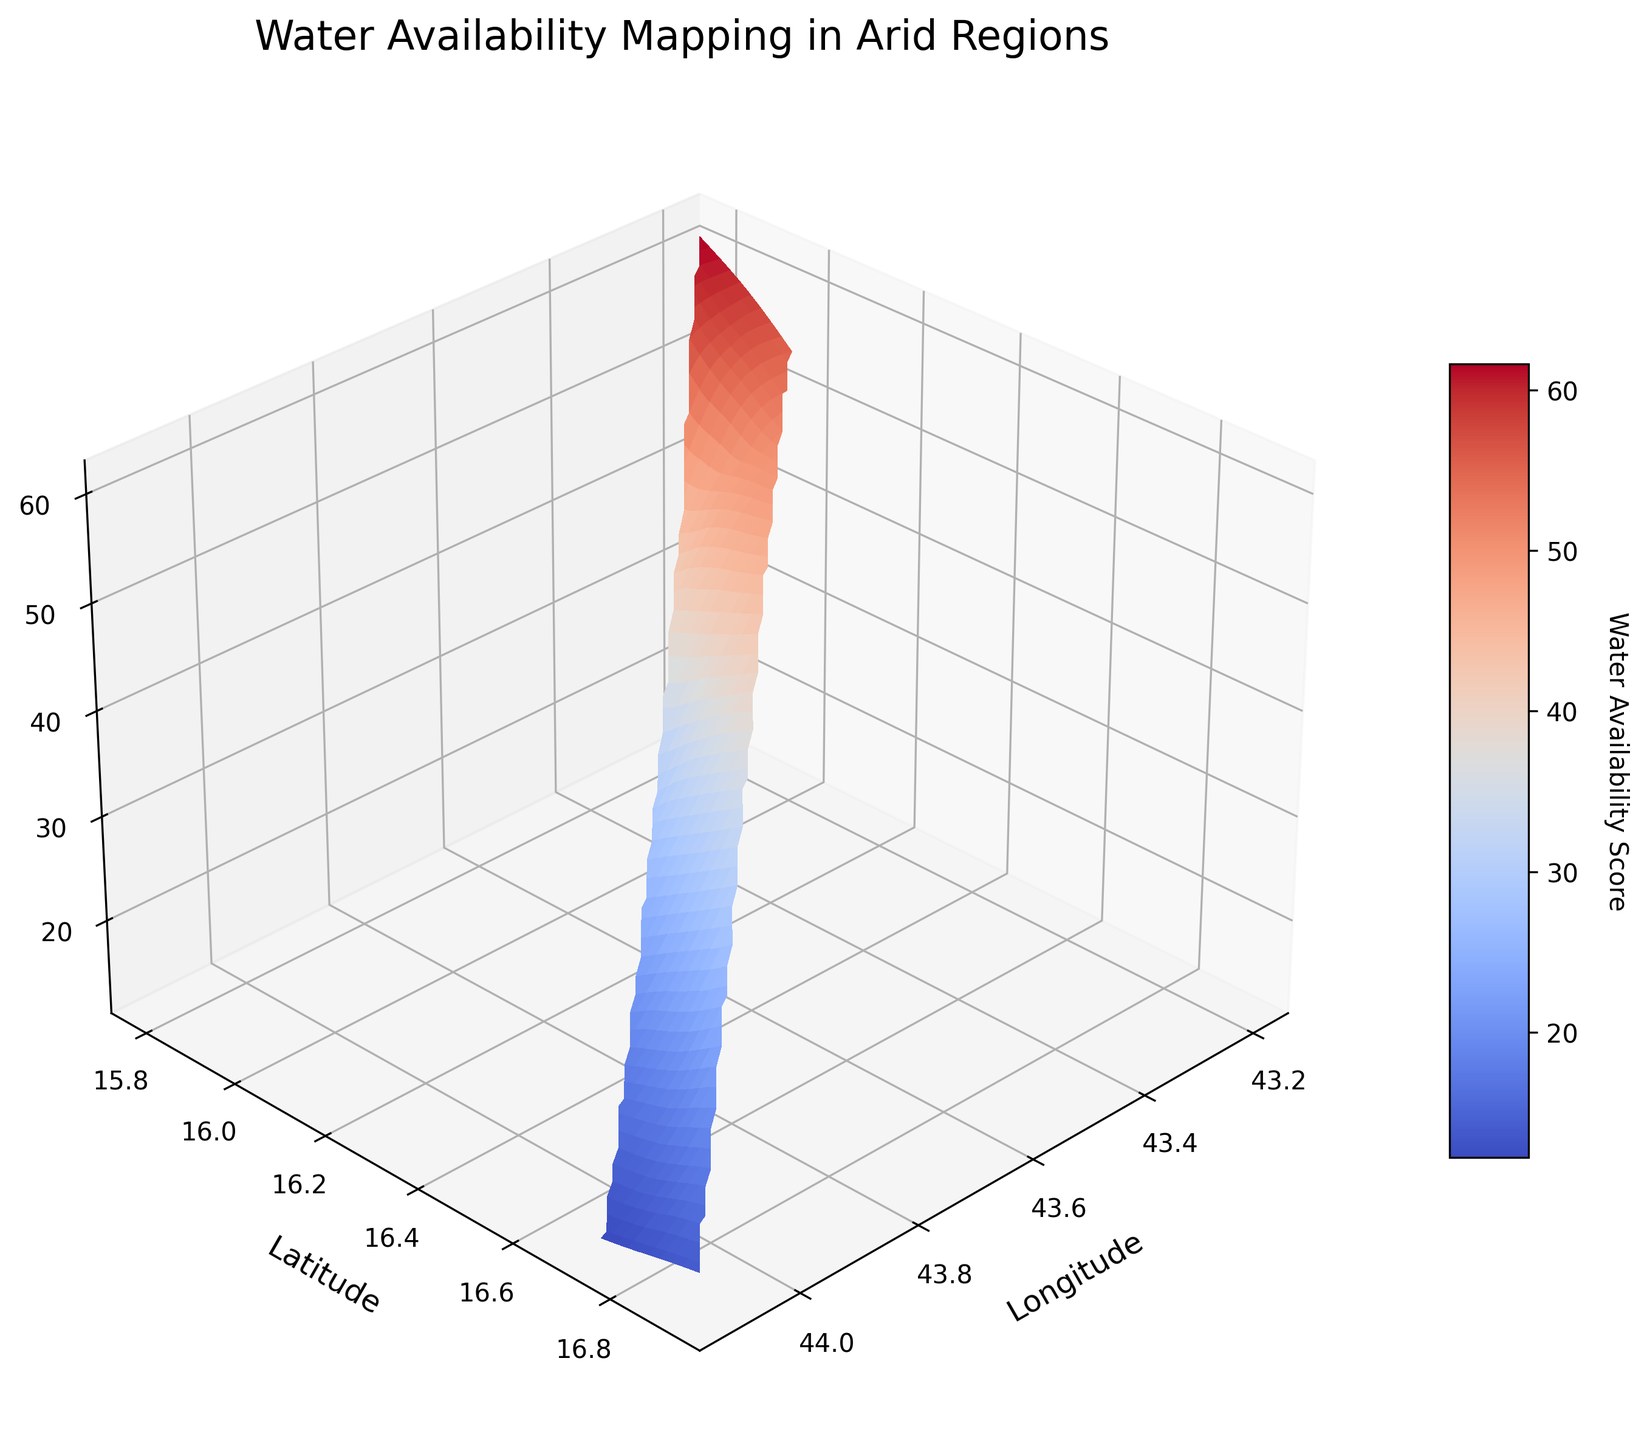What is the title of the plot? The title is displayed at the top of the plot, making it straightforward to find and identify.
Answer: Water Availability Mapping in Arid Regions What do the axes represent? The axis labels indicate the respective measures: the x-axis represents Longitude, the y-axis represents Latitude, and the z-axis represents the Water Availability Score.
Answer: Longitude, Latitude, Water Availability Score What color is used to represent the highest water availability score in the plot? The highest scores correspond to the color scheme used, which is typically indicated by the warm colors (like red) on the 'coolwarm' colormap.
Answer: Red Where is the highest water availability score located? To find the location, look for the highest point on the z-axis and trace down to the x and y-axes for the coordinates.
Answer: Around (43.2, 15.8) Does the water availability score generally increase or decrease as the latitude increases? Observing the surface plot, the score tends to decrease as the latitude values increase.
Answer: Decrease Which area, based on longitude, has the lowest water availability score? The lowest points on the z-axis need to be traced back to their corresponding x-axis values (longitude).
Answer: Around 44.1 How does water availability score vary along longitude 43.7? Check the values along the longitude 43.7 line on the plot and observe the changes on the z-axis.
Answer: Varies from about 30 to 27 What is the general trend of water availability scores along the latitude from 15.8 to 16.9? Examine changes in the z-values along the constant line of y from 15.8 to 16.9. The scores generally decrease as the latitude increases.
Answer: Decreasing Is there a notable pattern in water availability scores across the plotted region? Observing the surface, the pattern shows a general decline in water availability from the lower latitudes to the higher latitudes.
Answer: Yes, declining trend 